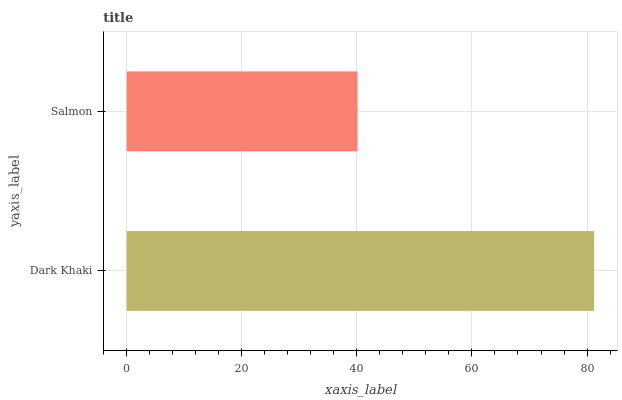Is Salmon the minimum?
Answer yes or no. Yes. Is Dark Khaki the maximum?
Answer yes or no. Yes. Is Salmon the maximum?
Answer yes or no. No. Is Dark Khaki greater than Salmon?
Answer yes or no. Yes. Is Salmon less than Dark Khaki?
Answer yes or no. Yes. Is Salmon greater than Dark Khaki?
Answer yes or no. No. Is Dark Khaki less than Salmon?
Answer yes or no. No. Is Dark Khaki the high median?
Answer yes or no. Yes. Is Salmon the low median?
Answer yes or no. Yes. Is Salmon the high median?
Answer yes or no. No. Is Dark Khaki the low median?
Answer yes or no. No. 